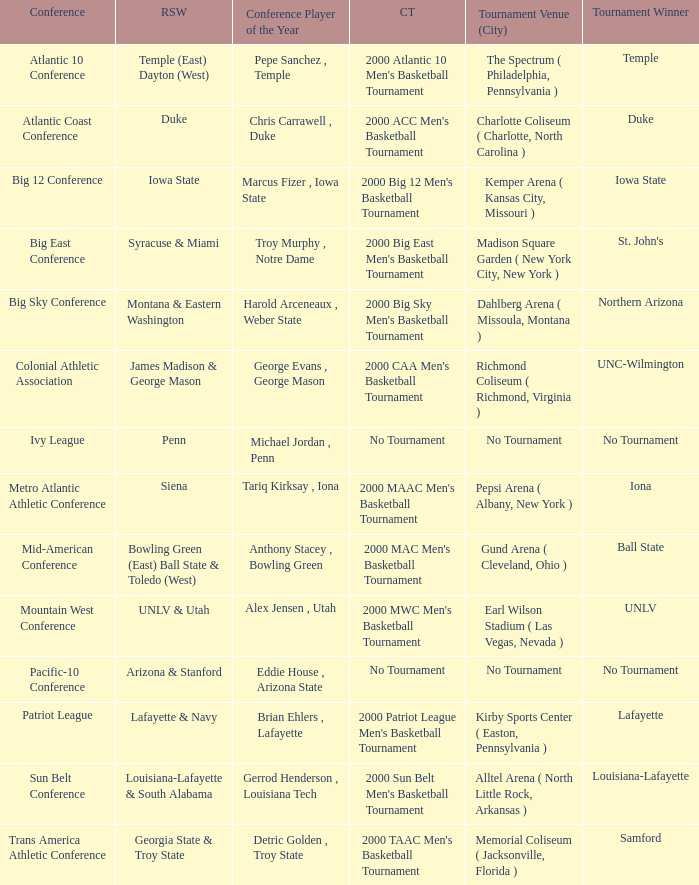Where was the Ivy League conference tournament? No Tournament. 